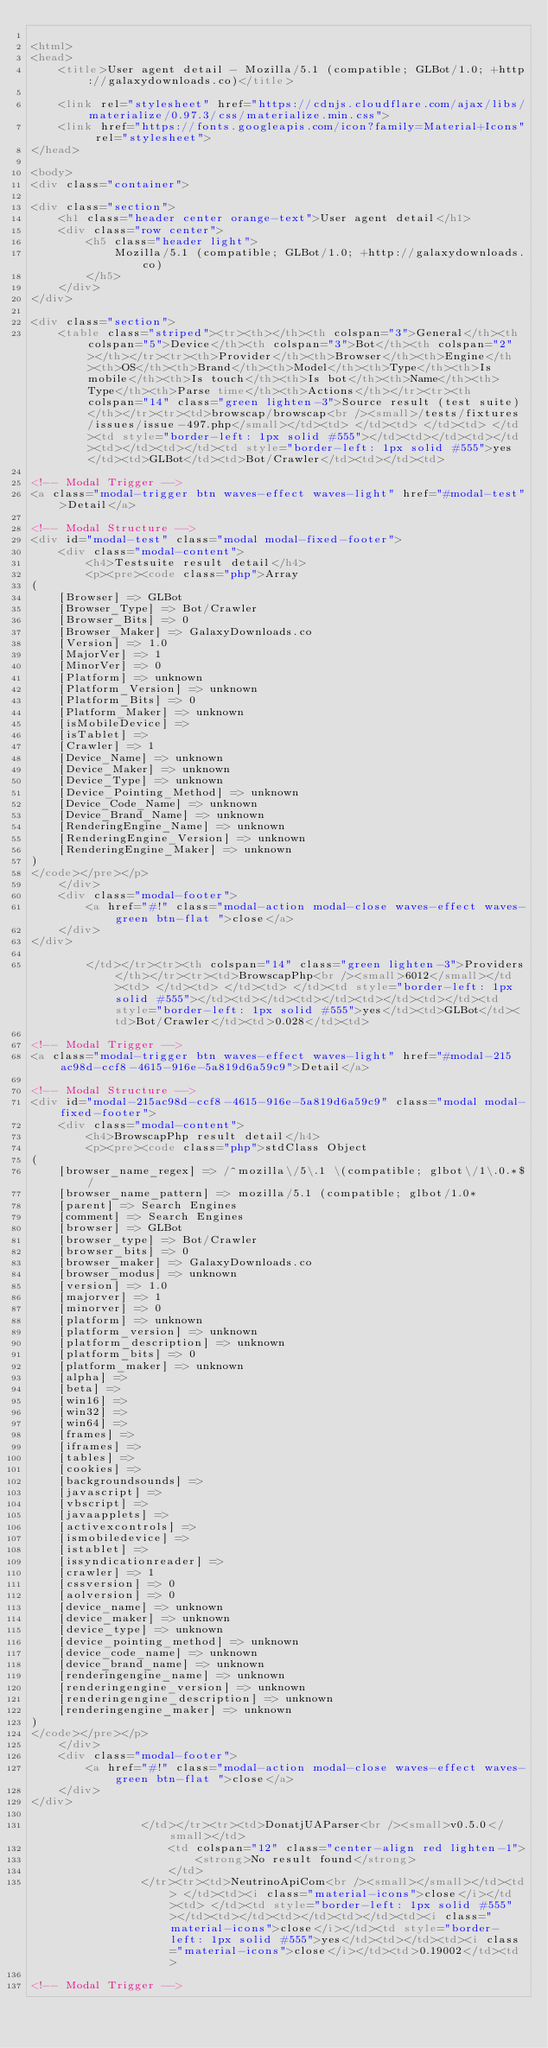Convert code to text. <code><loc_0><loc_0><loc_500><loc_500><_HTML_>
<html>
<head>
    <title>User agent detail - Mozilla/5.1 (compatible; GLBot/1.0; +http://galaxydownloads.co)</title>
        
    <link rel="stylesheet" href="https://cdnjs.cloudflare.com/ajax/libs/materialize/0.97.3/css/materialize.min.css">
    <link href="https://fonts.googleapis.com/icon?family=Material+Icons" rel="stylesheet">
</head>
        
<body>
<div class="container">
    
<div class="section">
	<h1 class="header center orange-text">User agent detail</h1>
	<div class="row center">
        <h5 class="header light">
            Mozilla/5.1 (compatible; GLBot/1.0; +http://galaxydownloads.co)
        </h5>
	</div>
</div>   

<div class="section">
    <table class="striped"><tr><th></th><th colspan="3">General</th><th colspan="5">Device</th><th colspan="3">Bot</th><th colspan="2"></th></tr><tr><th>Provider</th><th>Browser</th><th>Engine</th><th>OS</th><th>Brand</th><th>Model</th><th>Type</th><th>Is mobile</th><th>Is touch</th><th>Is bot</th><th>Name</th><th>Type</th><th>Parse time</th><th>Actions</th></tr><tr><th colspan="14" class="green lighten-3">Source result (test suite)</th></tr><tr><td>browscap/browscap<br /><small>/tests/fixtures/issues/issue-497.php</small></td><td> </td><td> </td><td> </td><td style="border-left: 1px solid #555"></td><td></td><td></td><td></td><td></td><td style="border-left: 1px solid #555">yes</td><td>GLBot</td><td>Bot/Crawler</td><td></td><td>
                
<!-- Modal Trigger -->
<a class="modal-trigger btn waves-effect waves-light" href="#modal-test">Detail</a>

<!-- Modal Structure -->
<div id="modal-test" class="modal modal-fixed-footer">
    <div class="modal-content">
        <h4>Testsuite result detail</h4>
        <p><pre><code class="php">Array
(
    [Browser] => GLBot
    [Browser_Type] => Bot/Crawler
    [Browser_Bits] => 0
    [Browser_Maker] => GalaxyDownloads.co
    [Version] => 1.0
    [MajorVer] => 1
    [MinorVer] => 0
    [Platform] => unknown
    [Platform_Version] => unknown
    [Platform_Bits] => 0
    [Platform_Maker] => unknown
    [isMobileDevice] => 
    [isTablet] => 
    [Crawler] => 1
    [Device_Name] => unknown
    [Device_Maker] => unknown
    [Device_Type] => unknown
    [Device_Pointing_Method] => unknown
    [Device_Code_Name] => unknown
    [Device_Brand_Name] => unknown
    [RenderingEngine_Name] => unknown
    [RenderingEngine_Version] => unknown
    [RenderingEngine_Maker] => unknown
)
</code></pre></p>
    </div>
    <div class="modal-footer">
        <a href="#!" class="modal-action modal-close waves-effect waves-green btn-flat ">close</a>
    </div>
</div>
                
        </td></tr><tr><th colspan="14" class="green lighten-3">Providers</th></tr><tr><td>BrowscapPhp<br /><small>6012</small></td><td> </td><td> </td><td> </td><td style="border-left: 1px solid #555"></td><td></td><td></td><td></td><td></td><td style="border-left: 1px solid #555">yes</td><td>GLBot</td><td>Bot/Crawler</td><td>0.028</td><td>
                
<!-- Modal Trigger -->
<a class="modal-trigger btn waves-effect waves-light" href="#modal-215ac98d-ccf8-4615-916e-5a819d6a59c9">Detail</a>

<!-- Modal Structure -->
<div id="modal-215ac98d-ccf8-4615-916e-5a819d6a59c9" class="modal modal-fixed-footer">
    <div class="modal-content">
        <h4>BrowscapPhp result detail</h4>
        <p><pre><code class="php">stdClass Object
(
    [browser_name_regex] => /^mozilla\/5\.1 \(compatible; glbot\/1\.0.*$/
    [browser_name_pattern] => mozilla/5.1 (compatible; glbot/1.0*
    [parent] => Search Engines
    [comment] => Search Engines
    [browser] => GLBot
    [browser_type] => Bot/Crawler
    [browser_bits] => 0
    [browser_maker] => GalaxyDownloads.co
    [browser_modus] => unknown
    [version] => 1.0
    [majorver] => 1
    [minorver] => 0
    [platform] => unknown
    [platform_version] => unknown
    [platform_description] => unknown
    [platform_bits] => 0
    [platform_maker] => unknown
    [alpha] => 
    [beta] => 
    [win16] => 
    [win32] => 
    [win64] => 
    [frames] => 
    [iframes] => 
    [tables] => 
    [cookies] => 
    [backgroundsounds] => 
    [javascript] => 
    [vbscript] => 
    [javaapplets] => 
    [activexcontrols] => 
    [ismobiledevice] => 
    [istablet] => 
    [issyndicationreader] => 
    [crawler] => 1
    [cssversion] => 0
    [aolversion] => 0
    [device_name] => unknown
    [device_maker] => unknown
    [device_type] => unknown
    [device_pointing_method] => unknown
    [device_code_name] => unknown
    [device_brand_name] => unknown
    [renderingengine_name] => unknown
    [renderingengine_version] => unknown
    [renderingengine_description] => unknown
    [renderingengine_maker] => unknown
)
</code></pre></p>
    </div>
    <div class="modal-footer">
        <a href="#!" class="modal-action modal-close waves-effect waves-green btn-flat ">close</a>
    </div>
</div>
                
                </td></tr><tr><td>DonatjUAParser<br /><small>v0.5.0</small></td>
                    <td colspan="12" class="center-align red lighten-1">
                        <strong>No result found</strong>
                    </td>
                </tr><tr><td>NeutrinoApiCom<br /><small></small></td><td> </td><td><i class="material-icons">close</i></td><td> </td><td style="border-left: 1px solid #555"></td><td></td><td></td><td></td><td><i class="material-icons">close</i></td><td style="border-left: 1px solid #555">yes</td><td></td><td><i class="material-icons">close</i></td><td>0.19002</td><td>
                
<!-- Modal Trigger --></code> 